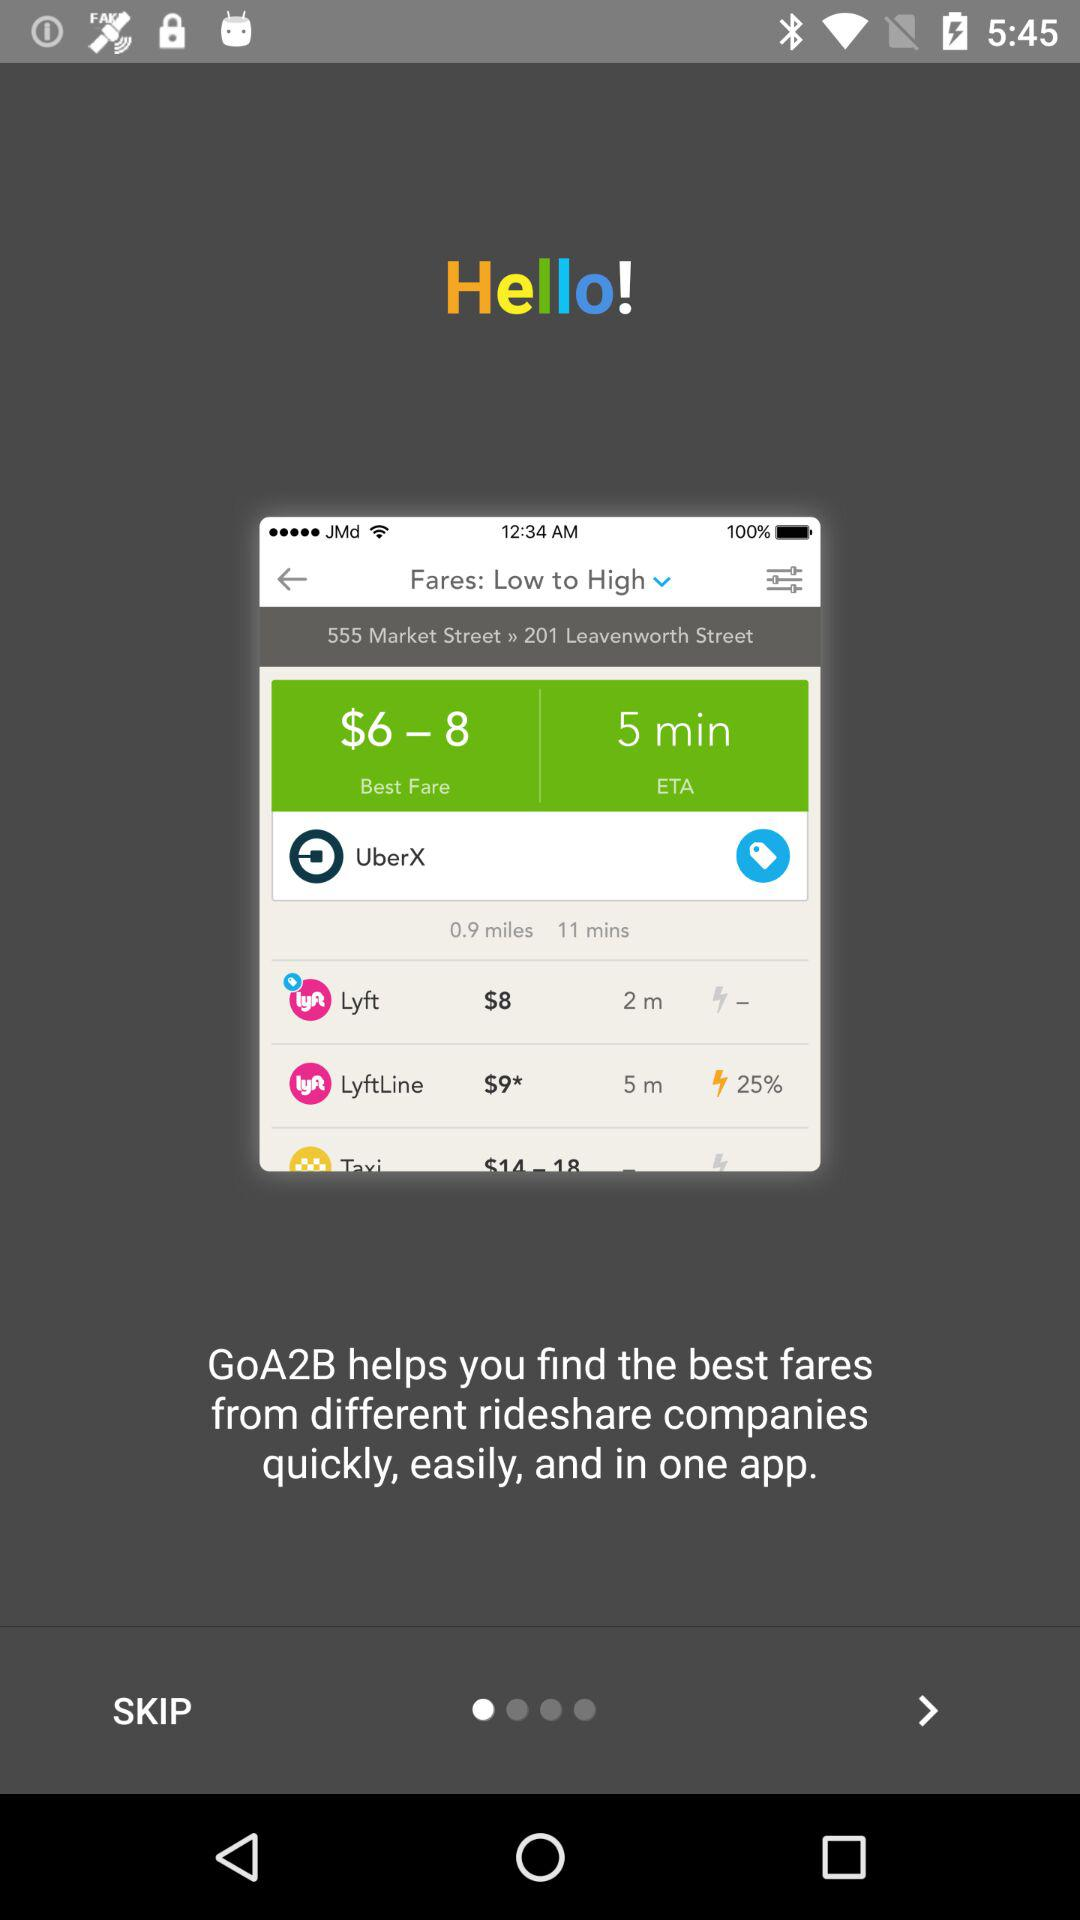What is the name of the application? The name of the application is "GoA2B". 